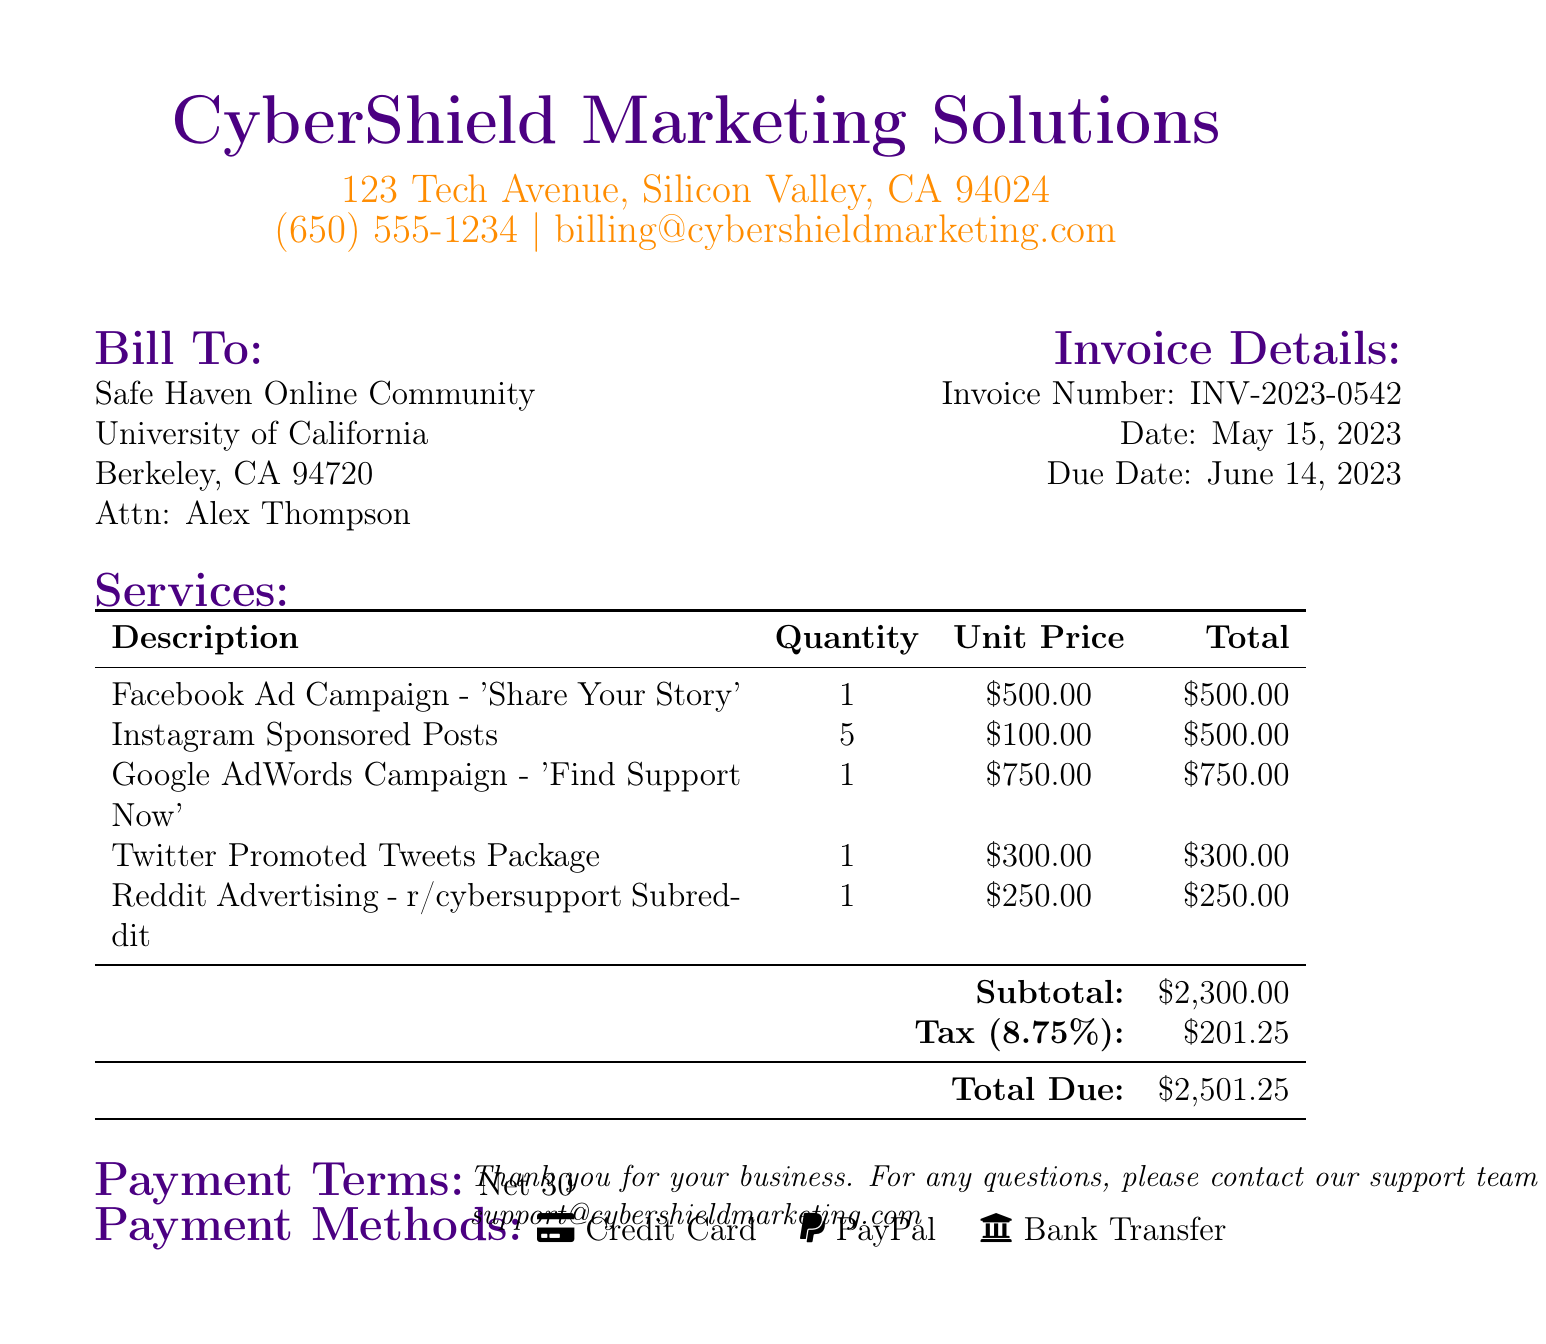What is the invoice number? The invoice number is found in the invoice details section of the document.
Answer: INV-2023-0542 What is the due date for the invoice? The due date is specified in the invoice details section.
Answer: June 14, 2023 What is the total amount due? The total amount due is calculated at the bottom of the table for services rendered.
Answer: $2,501.25 How many Instagram sponsored posts are included in the bill? The quantity for the Instagram sponsored posts is listed in the services section.
Answer: 5 What is the subtotal before tax? The subtotal can be found in the services table listed before the tax.
Answer: $2,300.00 Which service has the highest unit price? The unit prices for services are compared within the services table.
Answer: Google AdWords Campaign - 'Find Support Now' What payment methods are accepted? The payment methods are listed in a specific section of the document.
Answer: Credit Card, PayPal, Bank Transfer What is the tax rate applied to the bill? The tax rate is mentioned next to the tax amount in the document.
Answer: 8.75% What is the name of the recipient of the bill? The recipient's name is presented in the "Bill To" section of the document.
Answer: Alex Thompson 